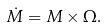Convert formula to latex. <formula><loc_0><loc_0><loc_500><loc_500>\dot { M } = M \times \Omega .</formula> 